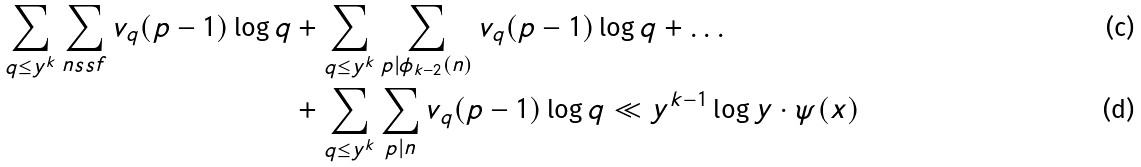Convert formula to latex. <formula><loc_0><loc_0><loc_500><loc_500>\sum _ { q \leq y ^ { k } } \sum _ { n s s f } v _ { q } ( p - 1 ) \log q & + \sum _ { q \leq y ^ { k } } \sum _ { p | \phi _ { k - 2 } ( n ) } v _ { q } ( p - 1 ) \log q + \dots \\ & + \sum _ { q \leq y ^ { k } } \sum _ { p | n } v _ { q } ( p - 1 ) \log q \ll y ^ { k - 1 } \log y \cdot \psi ( x )</formula> 